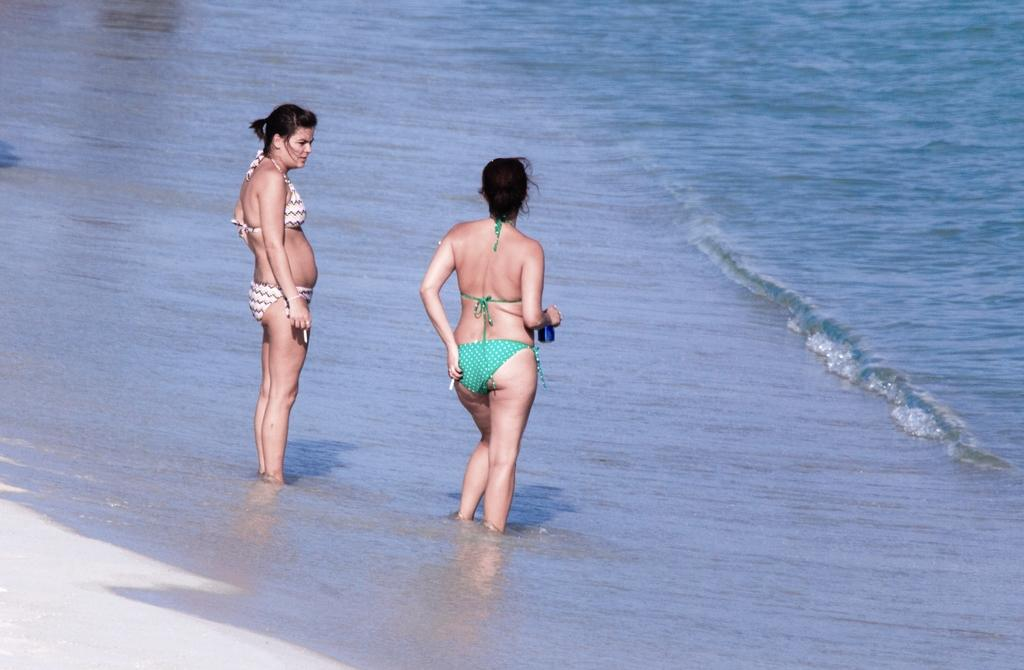How many people are in the image? There are two persons in the image. What are the persons wearing? The persons are wearing clothes. Where are the persons located in the image? The persons are standing in the beach. What type of foot can be seen in the image? There is no foot visible in the image; only the two persons standing in the beach are present. 